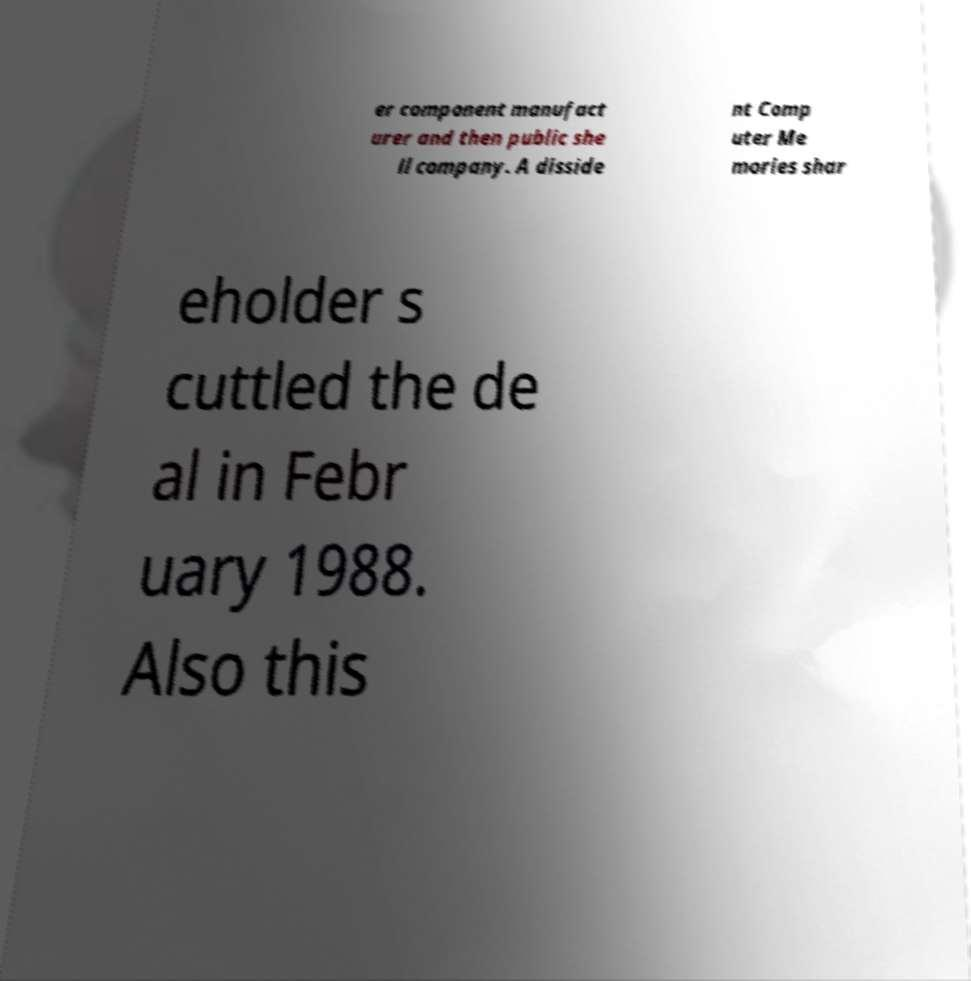Please read and relay the text visible in this image. What does it say? er component manufact urer and then public she ll company. A disside nt Comp uter Me mories shar eholder s cuttled the de al in Febr uary 1988. Also this 